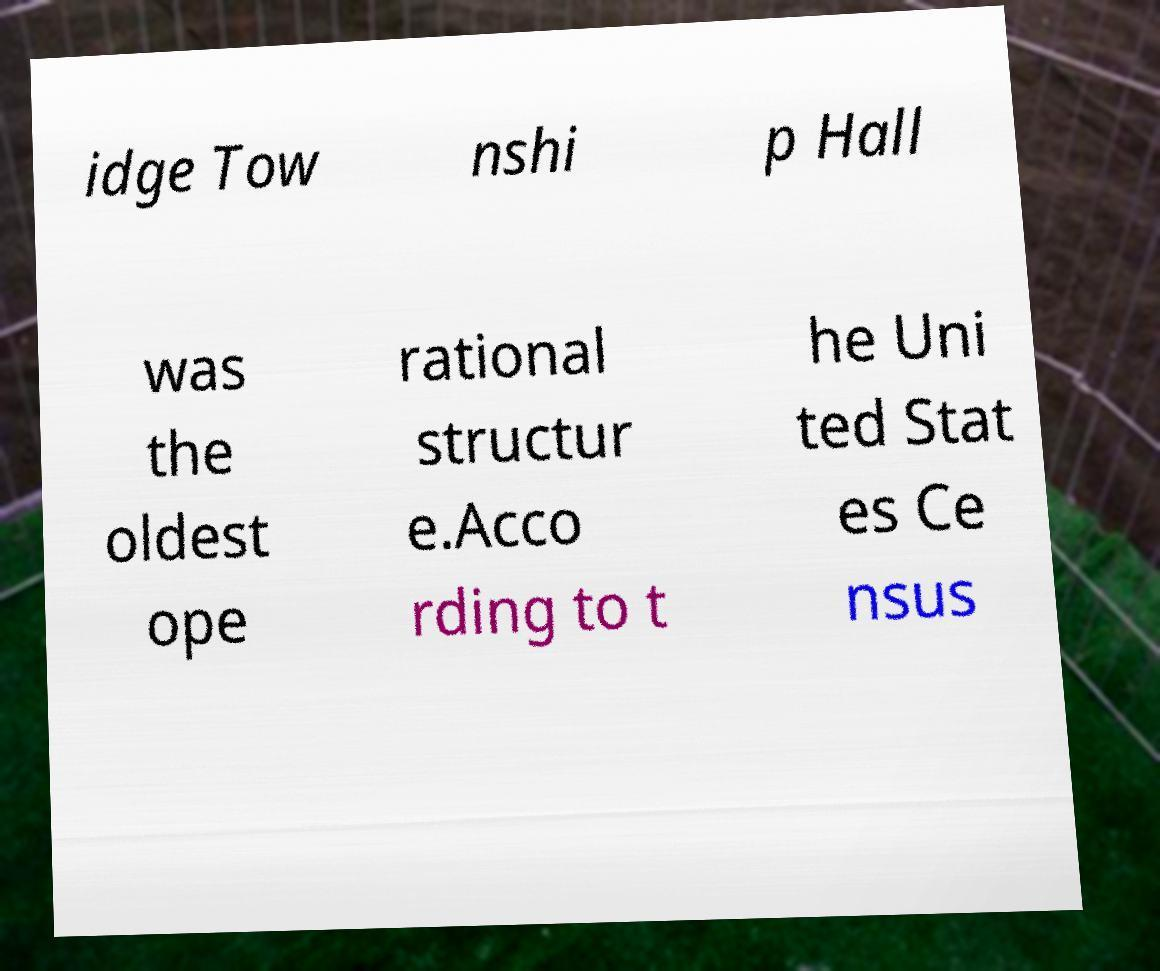Could you extract and type out the text from this image? idge Tow nshi p Hall was the oldest ope rational structur e.Acco rding to t he Uni ted Stat es Ce nsus 